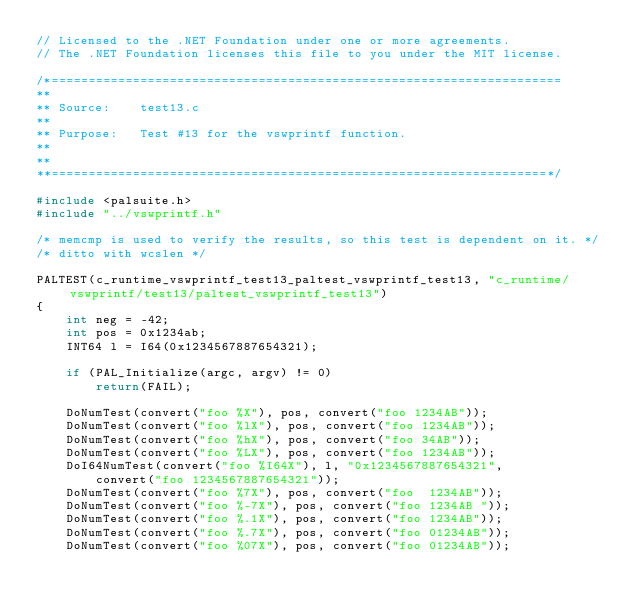Convert code to text. <code><loc_0><loc_0><loc_500><loc_500><_C++_>// Licensed to the .NET Foundation under one or more agreements.
// The .NET Foundation licenses this file to you under the MIT license.

/*=====================================================================
**
** Source:    test13.c
**
** Purpose:   Test #13 for the vswprintf function.
**
**
**===================================================================*/
 
#include <palsuite.h>
#include "../vswprintf.h"

/* memcmp is used to verify the results, so this test is dependent on it. */
/* ditto with wcslen */

PALTEST(c_runtime_vswprintf_test13_paltest_vswprintf_test13, "c_runtime/vswprintf/test13/paltest_vswprintf_test13")
{
    int neg = -42;
    int pos = 0x1234ab;
    INT64 l = I64(0x1234567887654321);

    if (PAL_Initialize(argc, argv) != 0)
        return(FAIL);

    DoNumTest(convert("foo %X"), pos, convert("foo 1234AB"));
    DoNumTest(convert("foo %lX"), pos, convert("foo 1234AB"));
    DoNumTest(convert("foo %hX"), pos, convert("foo 34AB"));
    DoNumTest(convert("foo %LX"), pos, convert("foo 1234AB"));
    DoI64NumTest(convert("foo %I64X"), l, "0x1234567887654321", 
        convert("foo 1234567887654321"));
    DoNumTest(convert("foo %7X"), pos, convert("foo  1234AB"));
    DoNumTest(convert("foo %-7X"), pos, convert("foo 1234AB "));
    DoNumTest(convert("foo %.1X"), pos, convert("foo 1234AB"));
    DoNumTest(convert("foo %.7X"), pos, convert("foo 01234AB"));
    DoNumTest(convert("foo %07X"), pos, convert("foo 01234AB"));</code> 